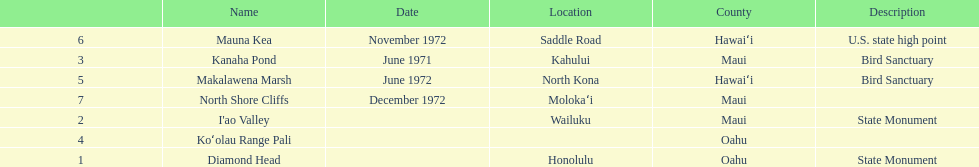How many dates are in 1972? 3. 